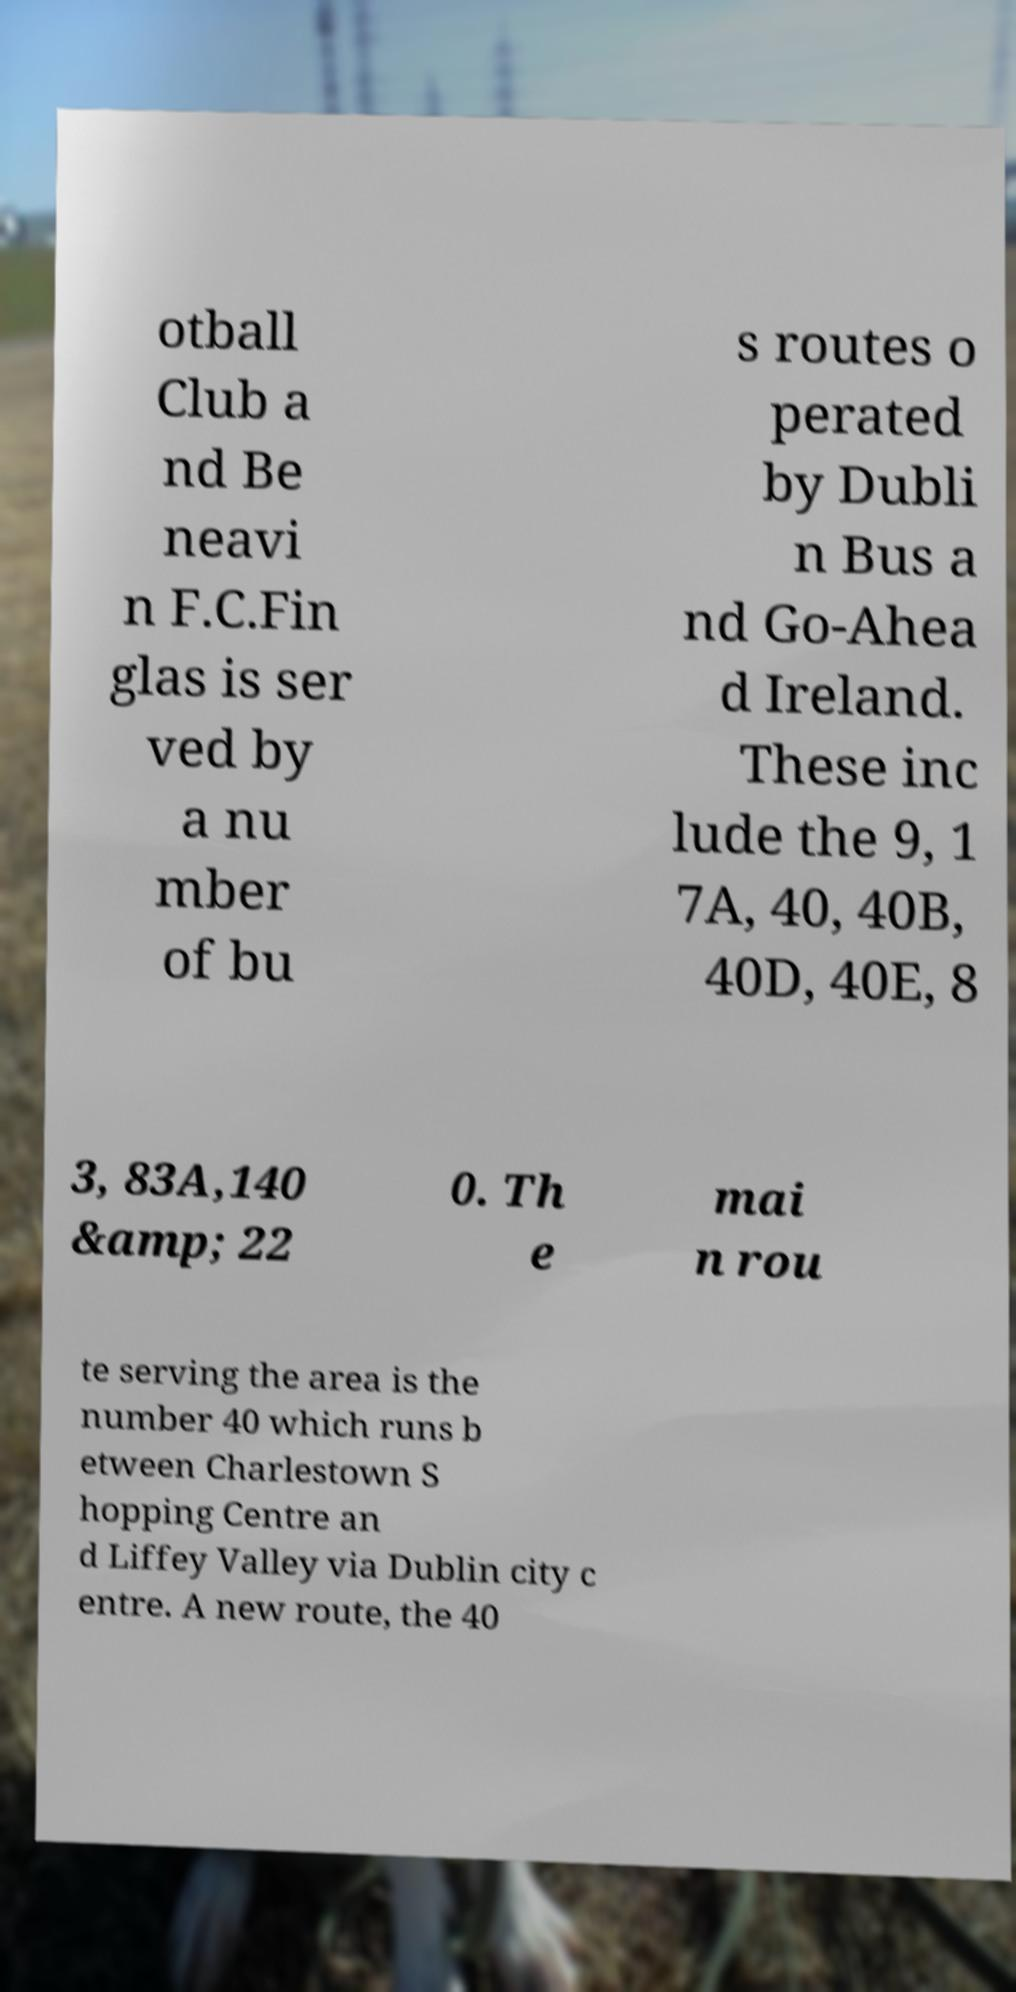What messages or text are displayed in this image? I need them in a readable, typed format. otball Club a nd Be neavi n F.C.Fin glas is ser ved by a nu mber of bu s routes o perated by Dubli n Bus a nd Go-Ahea d Ireland. These inc lude the 9, 1 7A, 40, 40B, 40D, 40E, 8 3, 83A,140 &amp; 22 0. Th e mai n rou te serving the area is the number 40 which runs b etween Charlestown S hopping Centre an d Liffey Valley via Dublin city c entre. A new route, the 40 